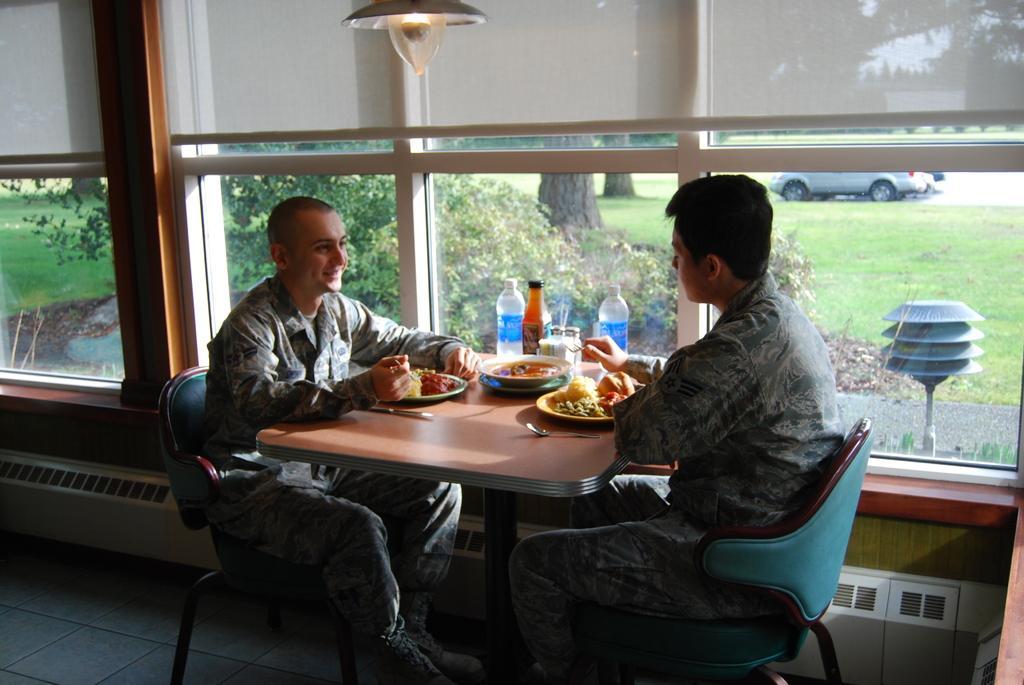In one or two sentences, can you explain what this image depicts? These two persons are sitting on chairs. In-front of them there is a table, on this table there is a plate, bowl, bottles, spoon and knife. From this window we can able to see grass, trees and vehicle. On top there is a light. 